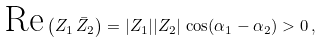Convert formula to latex. <formula><loc_0><loc_0><loc_500><loc_500>\text {Re} \left ( Z _ { 1 } \, \bar { Z } _ { 2 } \right ) = | Z _ { 1 } | | Z _ { 2 } | \, \cos ( \alpha _ { 1 } - \alpha _ { 2 } ) > 0 \, ,</formula> 